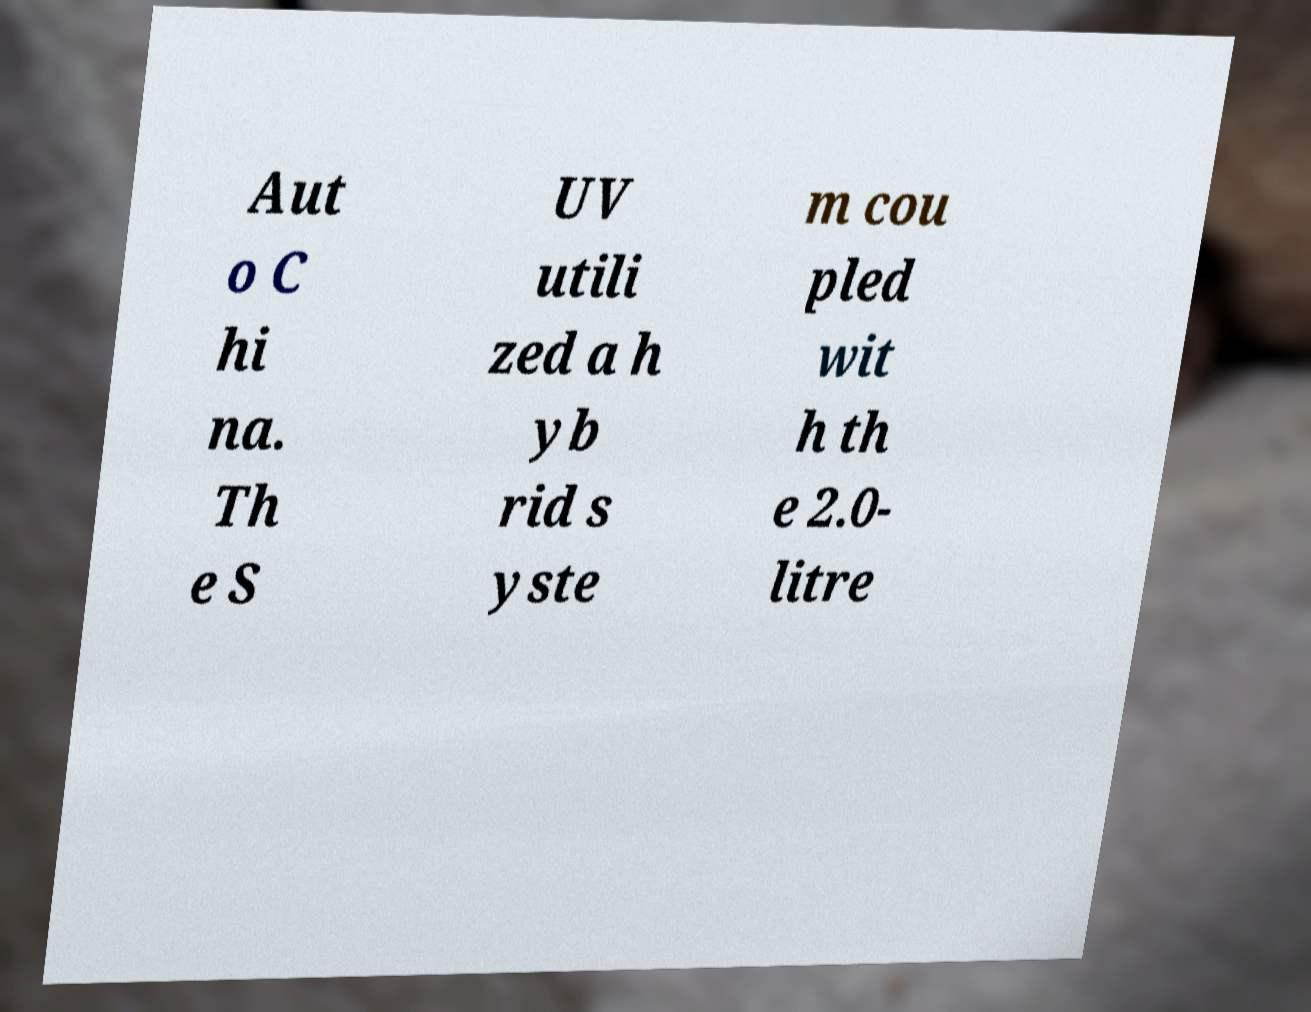I need the written content from this picture converted into text. Can you do that? Aut o C hi na. Th e S UV utili zed a h yb rid s yste m cou pled wit h th e 2.0- litre 